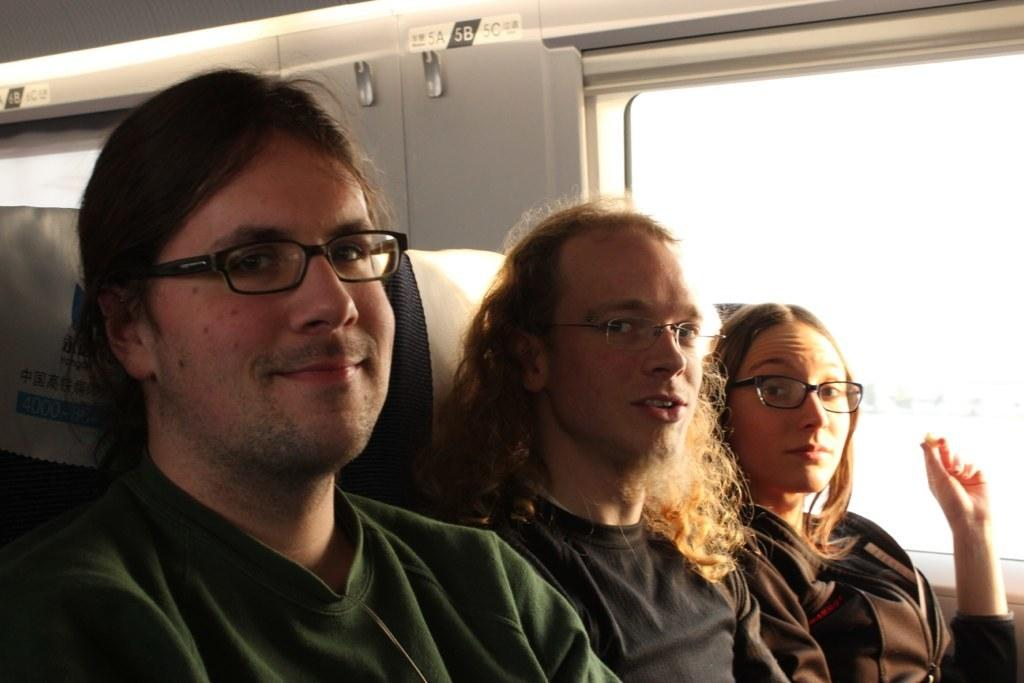How many people are in the vehicle in the image? There are three people sitting in the vehicle. What can be seen on the right side of the vehicle? The vehicle has a window on the right side. What type of corn can be seen growing in the vehicle? There is no corn present in the vehicle; it is a vehicle with people inside. How does the acoustics of the vehicle affect the conversation between the passengers? The provided facts do not mention anything about the acoustics of the vehicle, so we cannot determine how it affects the conversation between the passengers. 